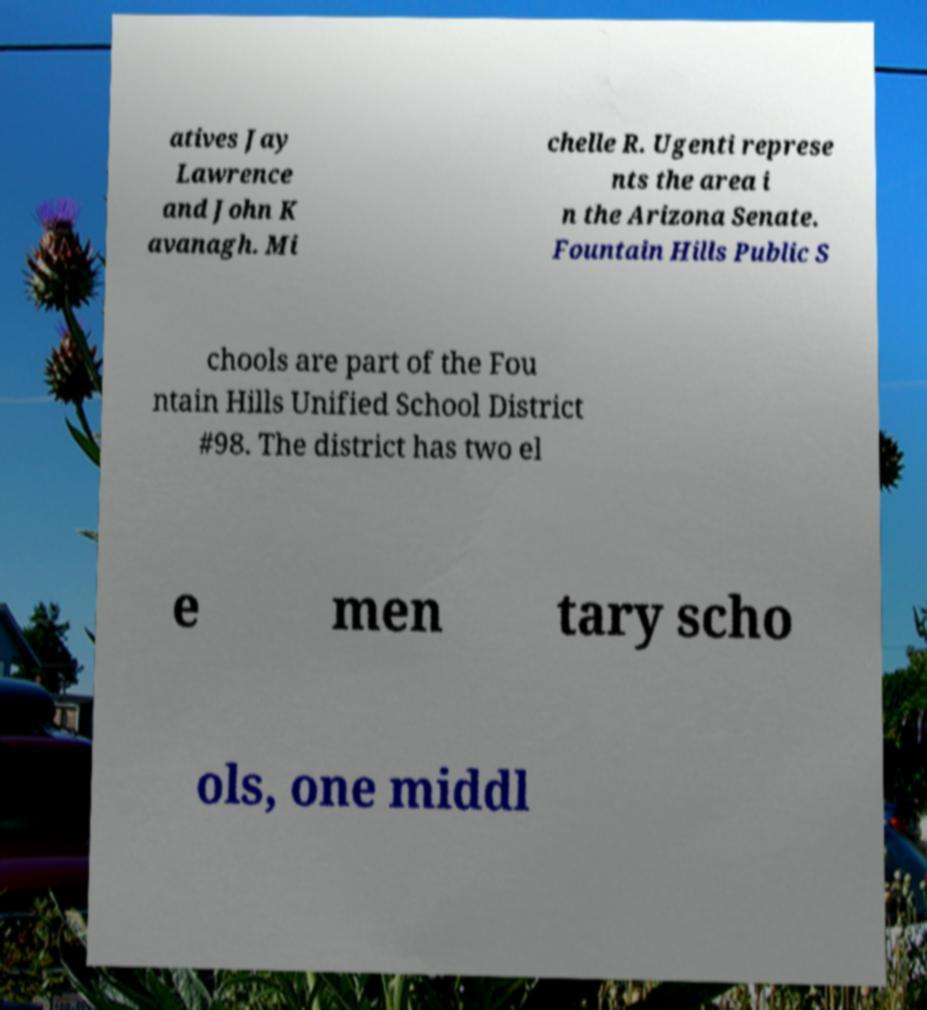Please identify and transcribe the text found in this image. atives Jay Lawrence and John K avanagh. Mi chelle R. Ugenti represe nts the area i n the Arizona Senate. Fountain Hills Public S chools are part of the Fou ntain Hills Unified School District #98. The district has two el e men tary scho ols, one middl 